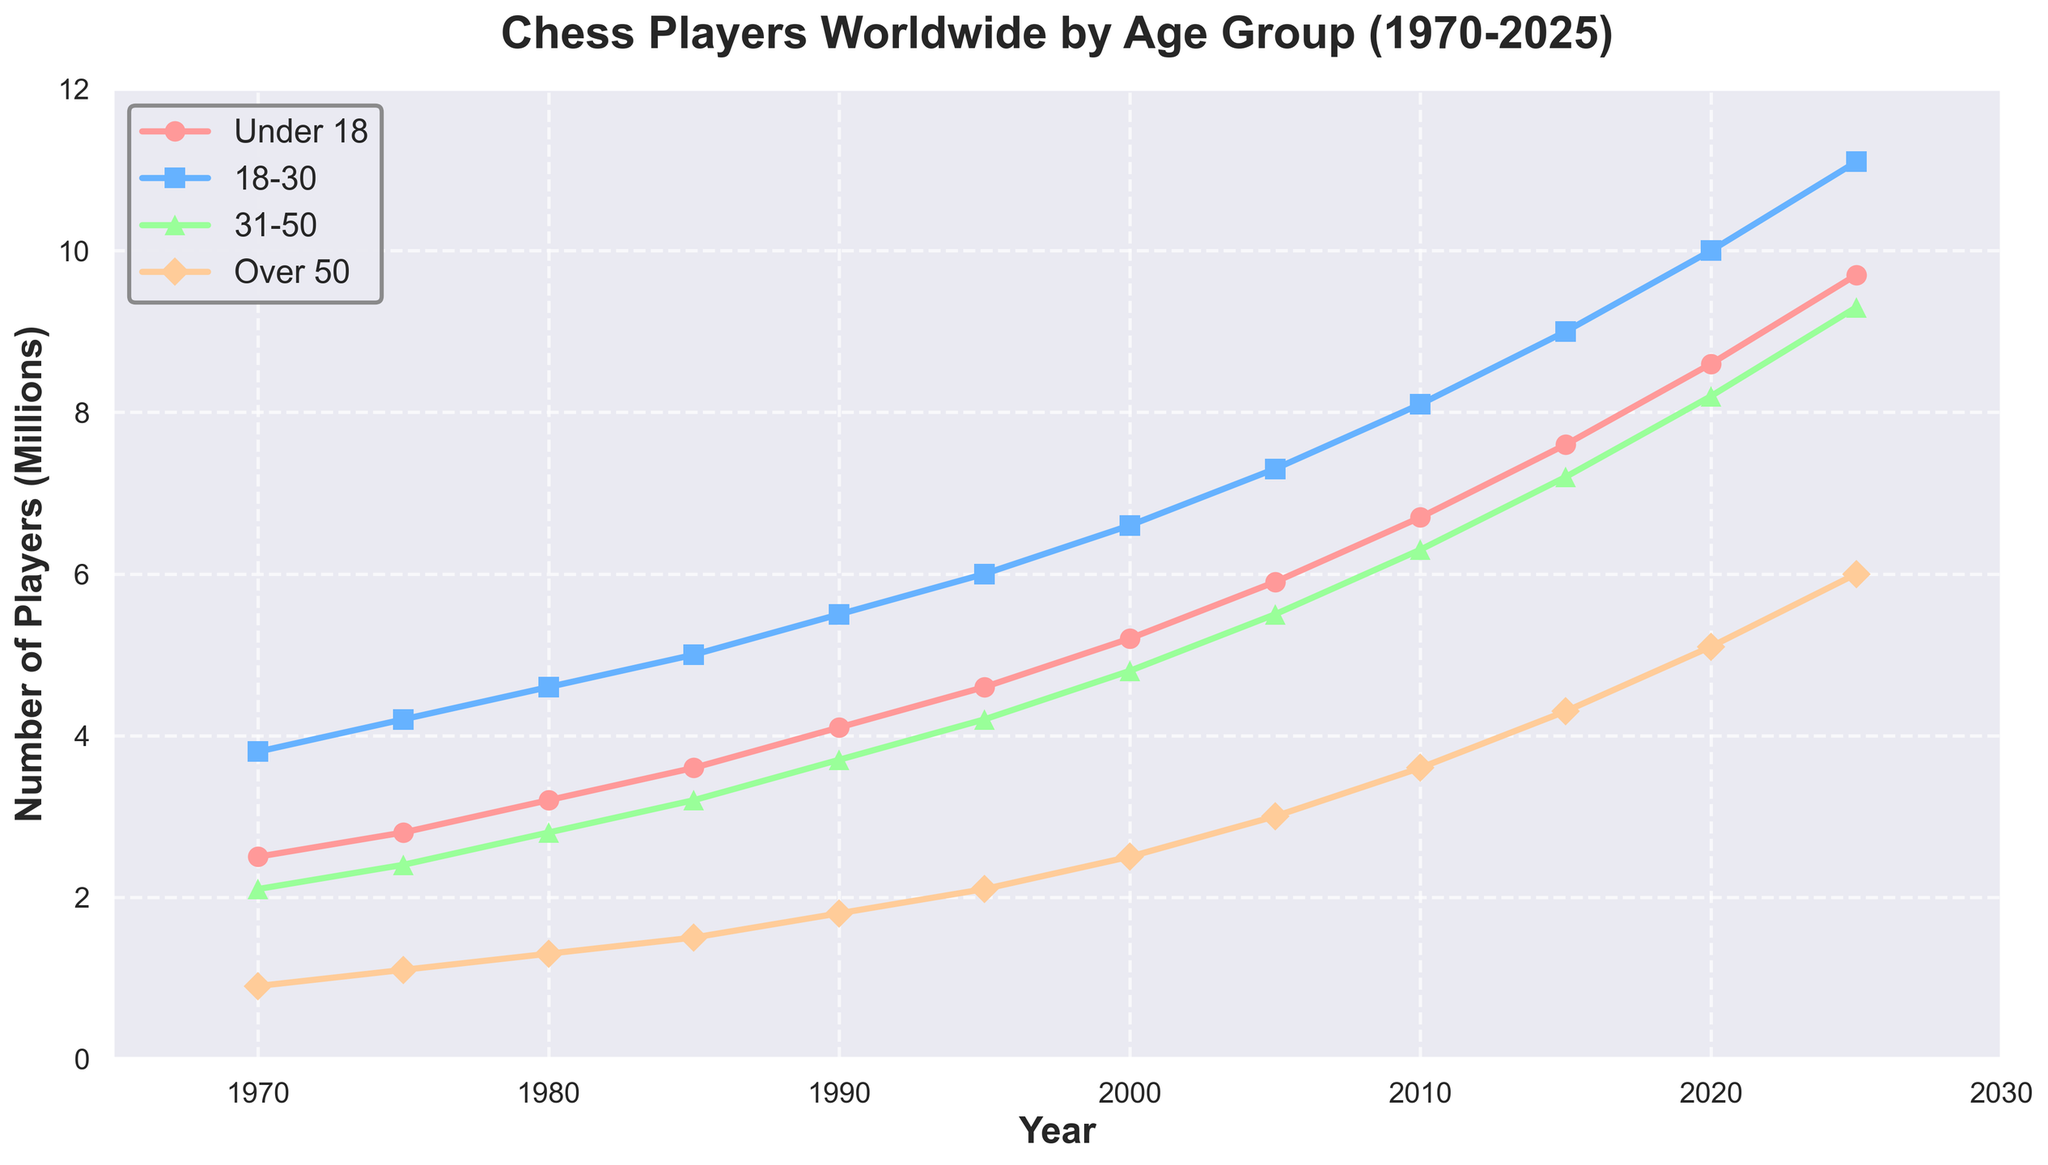What year had the largest increase in the number of chess players under 18? To determine the year with the largest increase, we calculate the difference in the number of players under 18 for each consecutive time period. The largest increase is from 2020 to 2025, where the numbers go from 8.6 million to 9.7 million, an increase of 1.1 million.
Answer: 2025 In what year did the number of players aged 31-50 surpass 7 million? We look at the data for the age group 31-50 and compare it to 7 million. The number surpasses 7 million between 2015 and 2020, as data shows it reaches 8.2 million in 2020.
Answer: 2020 Which age group had the highest growth from 1970 to 2025? Calculate the difference in the number of players for each age group between 1970 and 2025. For Under 18, the increase is from 2.5 million to 9.7 million = 7.2 million. For 18-30, it's from 3.8 million to 11.1 million = 7.3 million. For 31-50, it's from 2.1 million to 9.3 million = 7.2 million. For Over 50, it's from 0.9 million to 6 million = 5.1 million. The highest growth is in the 18-30 age group.
Answer: 18-30 In 1990, how does the number of players over 50 compare to those under 18? Checking the 1990 data, players under 18 are 4.1 million, and players over 50 are 1.8 million. Therefore, fewer players over 50 compared to under 18.
Answer: Less What is the average number of players aged 18-30 from 1970 to 2025? Sum the numbers for the 18-30 age group across all years and divide by the number of years: (3.8 + 4.2 + 4.6 + 5 + 5.5 + 6 + 6.6 + 7.3 + 8.1 + 9 + 10 + 11.1) million. This sums to 81.2 million over 12 years. Average = 81.2 / 12 ≈ 6.77 million.
Answer: 6.77 million By how much did the number of players aged 31-50 increase from 2000 to 2010? For the 31-50 age group: 2010 had 6.3 million players, and 2000 had 4.8 million. The increase is 6.3 - 4.8 = 1.5 million.
Answer: 1.5 million Which age group shows the most consistent growth trend from 1970 to 2025? By examining the line trends, the 18-30 age group consistently increases in a relatively linear fashion without significant fluctuations, indicating steady growth.
Answer: 18-30 In 2025, how do the numbers of players aged Under 18 and Over 50 compare? Checking the 2025 data, players Under 18 are 9.7 million, and players Over 50 are 6 million. Thus, there are more players Under 18 compared to Over 50.
Answer: More From 1980 to 1990, which age group had the smallest increase in the number of players? Calculate the increase for each group: Under 18 (4.1 - 3.2 = 0.9 million), 18-30 (5.5 - 4.6 = 0.9 million), 31-50 (3.7 - 2.8 = 0.9 million), Over 50 (1.8 - 1.3 = 0.5 million). The smallest increase is in the Over 50 group.
Answer: Over 50 What is the total number of chess players of all age groups in the year 2000? Sum the number of players for all age groups in 2000: 5.2 + 6.6 + 4.8 + 2.5 = 19.1 million.
Answer: 19.1 million 